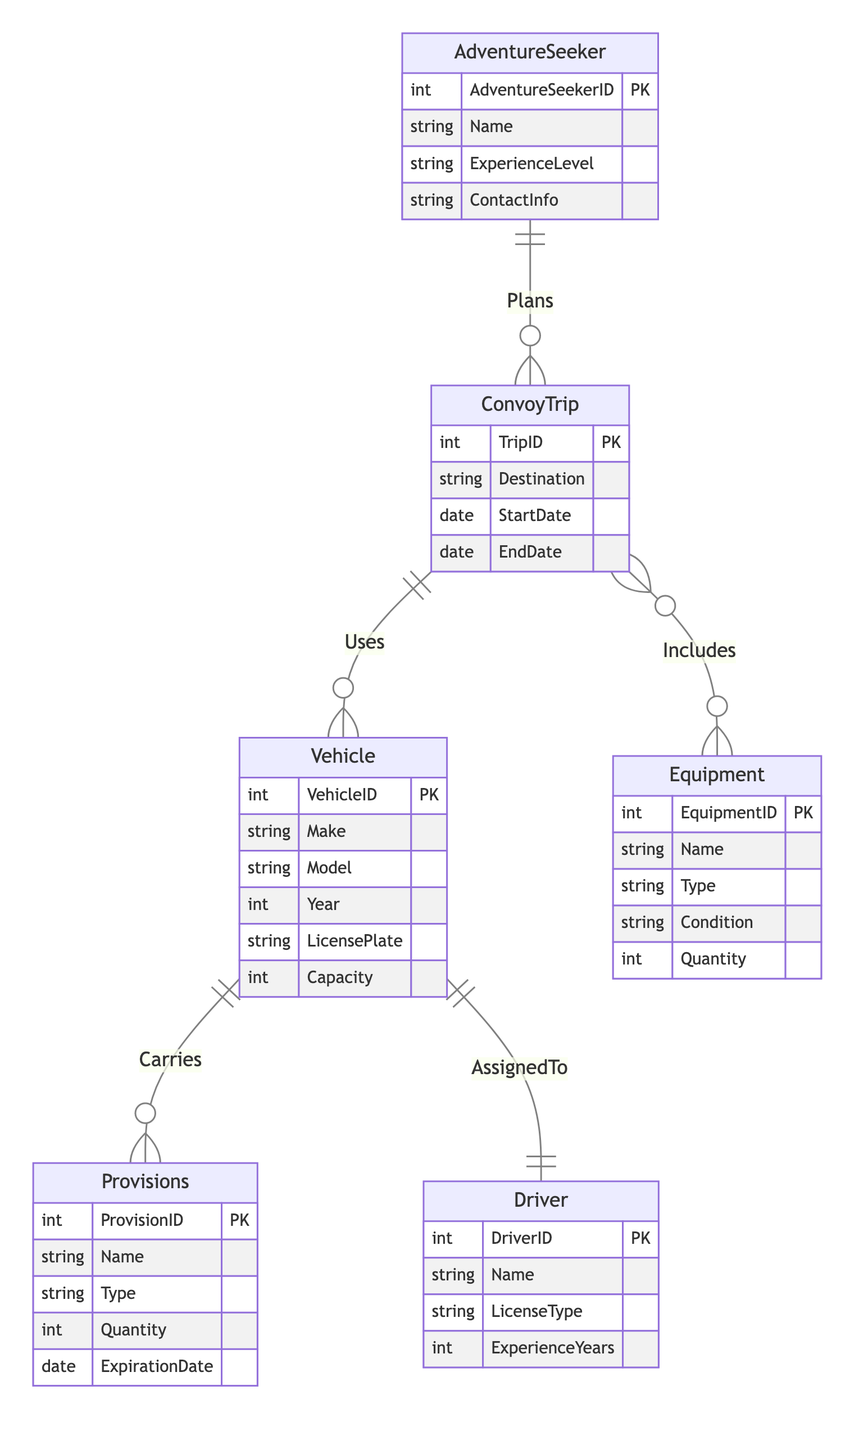What is the primary key for the Equipment entity? The primary key for the Equipment entity is EquipmentID, as indicated by the notation in the diagram.
Answer: EquipmentID How many attributes does the Driver entity have? The Driver entity has four attributes: DriverID, Name, LicenseType, and ExperienceYears. This is counted directly from the entity's attributes in the diagram.
Answer: Four What relationship exists between ConvoyTrip and Equipment? The relationship between ConvoyTrip and Equipment is "Includes," which describes that a ConvoyTrip can have multiple Equipment items associated with it.
Answer: Includes What is the cardinality of the relationship between Vehicle and Provisions? The cardinality of the relationship between Vehicle and Provisions is "One-to-Many," indicating that one Vehicle can carry multiple Provisions. This is specified in the relationship details in the diagram.
Answer: One-to-Many How many entities are there in total in this diagram? There are six entities in total: AdventureSeeker, ConvoyTrip, Vehicle, Equipment, Provisions, and Driver. This can be verified by counting the entities listed in the diagram.
Answer: Six Which entity is related to AdventureSeeker through the Plans relationship? ConvoyTrip is related to AdventureSeeker through the Plans relationship, meaning an AdventureSeeker can plan multiple ConvoyTrips. This relationship is explicitly stated in the diagram.
Answer: ConvoyTrip What does the term "AssignedTo" signify in the diagram? The term "AssignedTo" signifies a one-to-one relationship between Vehicle and Driver, indicating that each Vehicle is assigned to exactly one Driver. This relationship type is detailed in the diagram's key.
Answer: One-to-One How many distinct relationships connect the ConvoyTrip entity? The ConvoyTrip entity is connected by three distinct relationships: Plans, Uses, and Includes, showing how it interacts with AdventureSeeker, Vehicle, and Equipment, respectively. This can be determined by analyzing the relationships stemming from ConvoyTrip.
Answer: Three What is the relationship between Vehicle and Driver? The relationship between Vehicle and Driver is "AssignedTo," indicating that there is a direct assignment of one Driver to one Vehicle. This is explicitly mentioned in the diagram.
Answer: AssignedTo 